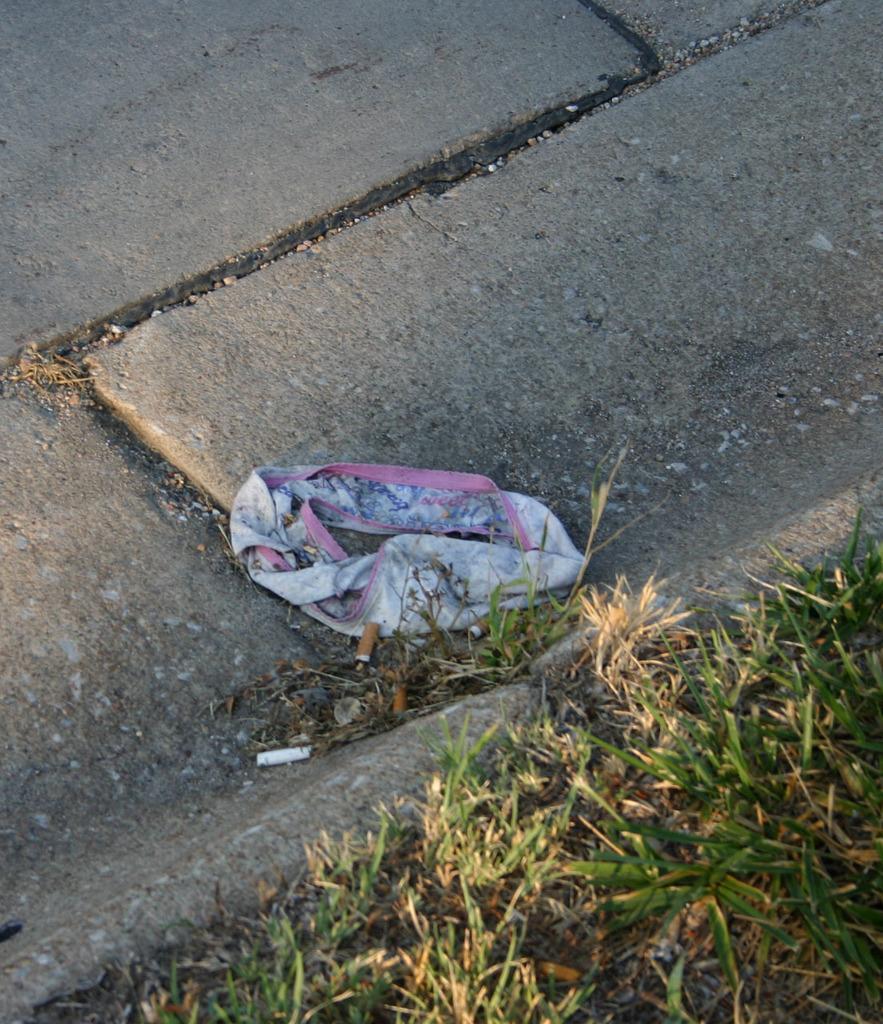Can you describe this image briefly? This image consists consists of a cloth on the road. At the bottom, there is green grass on the ground. And we can see the cigarette butts on the ground. 